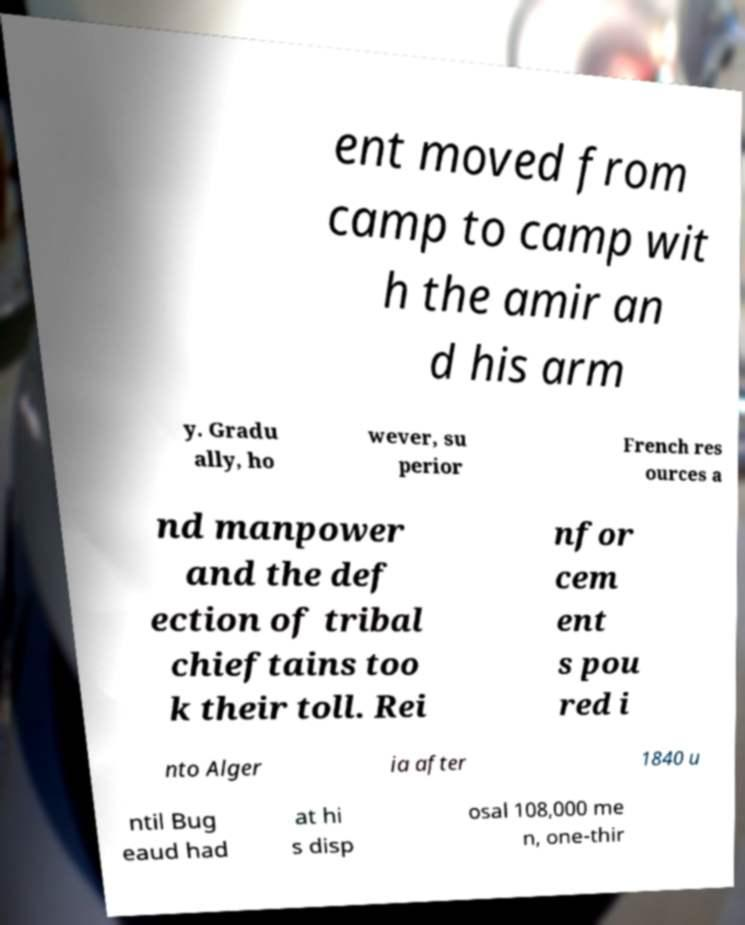Can you read and provide the text displayed in the image?This photo seems to have some interesting text. Can you extract and type it out for me? ent moved from camp to camp wit h the amir an d his arm y. Gradu ally, ho wever, su perior French res ources a nd manpower and the def ection of tribal chieftains too k their toll. Rei nfor cem ent s pou red i nto Alger ia after 1840 u ntil Bug eaud had at hi s disp osal 108,000 me n, one-thir 